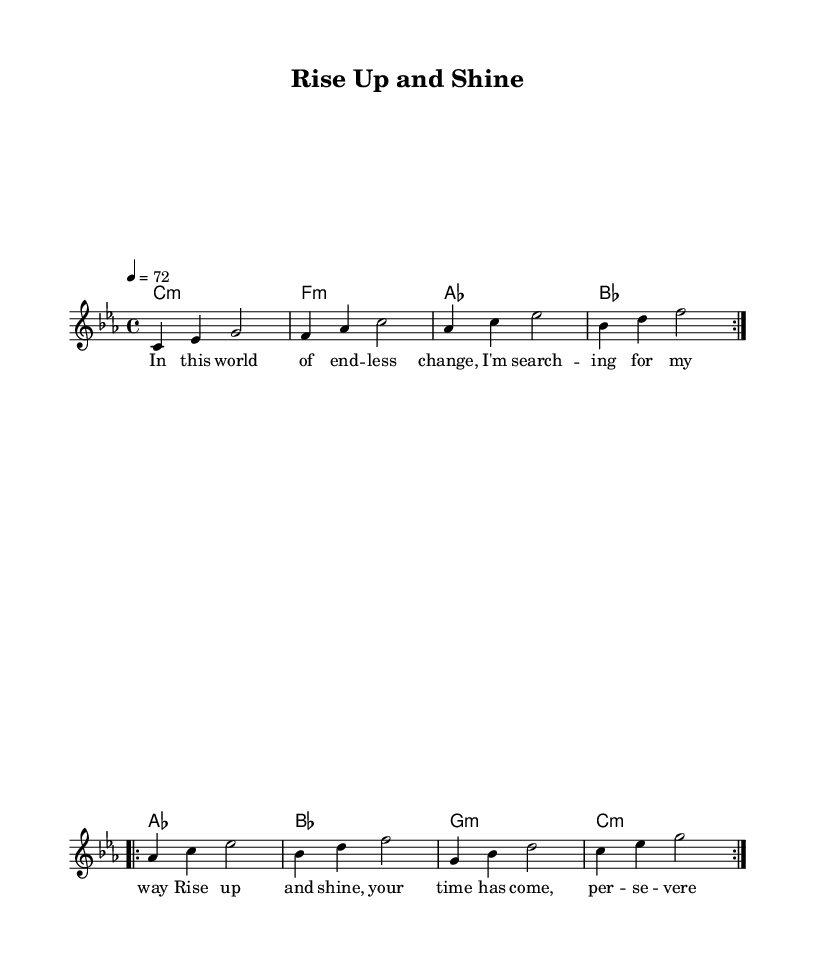What is the key signature of this music? The key signature is C minor, which has three flats (B flat, E flat, and A flat). This is indicated at the beginning of the sheet music.
Answer: C minor What is the time signature of this music? The time signature is 4/4, meaning there are four beats in each measure and the quarter note gets one beat. This is noted at the beginning next to the key signature.
Answer: 4/4 What is the tempo marking for this piece? The tempo marking is 4 equals 72, indicating that there are 72 quarter note beats per minute. This is found at the top after the time signature.
Answer: 72 How many measures are in the melody section? The melody section consists of 8 measures, as shown by counting the repeated phrases and their corresponding counts. Each repeat is counted as two, starting from the first measure.
Answer: 8 What is the first line of lyrics in this piece? The first line of lyrics is "In this world of end -- less change, I'm search -- ing for my way," as displayed under the melody in the lyric section of the score.
Answer: In this world of end -- less change, I'm search -- ing for my way What harmonic progression is used in the first half of the song? The first half of the harmonic progression follows C minor, F minor, A flat, and B flat chords. This can be identified by examining the chord symbols provided under the melody.
Answer: C minor, F minor, A flat, B flat What genre does this music belong to? This music belongs to the Roots Reggae genre, characterized by spiritual and socially conscious themes. This can be inferred from the title "Rise Up and Shine" and the lyrical content focusing on perseverance.
Answer: Roots reggae 